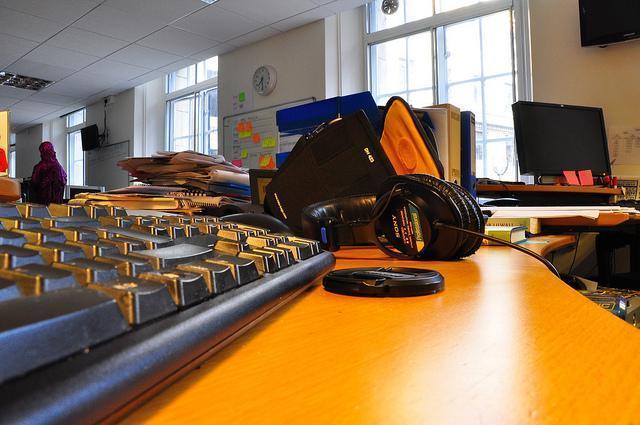How many tvs are visible?
Give a very brief answer. 2. How many bowls are on the tray?
Give a very brief answer. 0. 